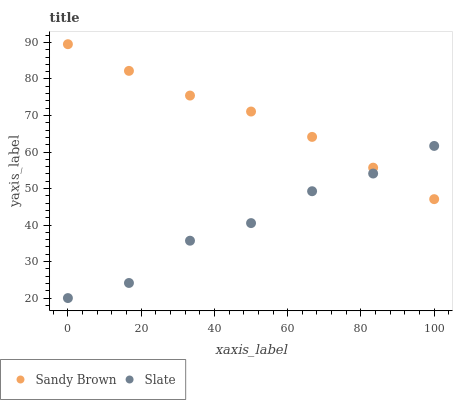Does Slate have the minimum area under the curve?
Answer yes or no. Yes. Does Sandy Brown have the maximum area under the curve?
Answer yes or no. Yes. Does Sandy Brown have the minimum area under the curve?
Answer yes or no. No. Is Sandy Brown the smoothest?
Answer yes or no. Yes. Is Slate the roughest?
Answer yes or no. Yes. Is Sandy Brown the roughest?
Answer yes or no. No. Does Slate have the lowest value?
Answer yes or no. Yes. Does Sandy Brown have the lowest value?
Answer yes or no. No. Does Sandy Brown have the highest value?
Answer yes or no. Yes. Does Slate intersect Sandy Brown?
Answer yes or no. Yes. Is Slate less than Sandy Brown?
Answer yes or no. No. Is Slate greater than Sandy Brown?
Answer yes or no. No. 